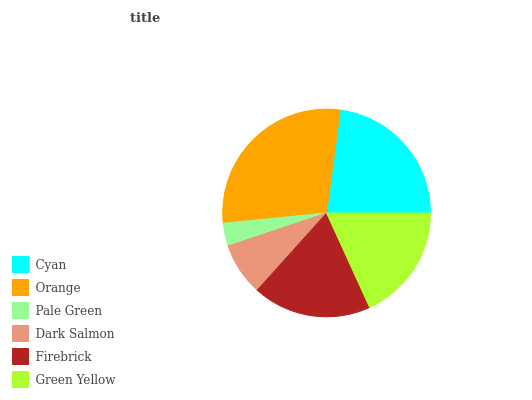Is Pale Green the minimum?
Answer yes or no. Yes. Is Orange the maximum?
Answer yes or no. Yes. Is Orange the minimum?
Answer yes or no. No. Is Pale Green the maximum?
Answer yes or no. No. Is Orange greater than Pale Green?
Answer yes or no. Yes. Is Pale Green less than Orange?
Answer yes or no. Yes. Is Pale Green greater than Orange?
Answer yes or no. No. Is Orange less than Pale Green?
Answer yes or no. No. Is Firebrick the high median?
Answer yes or no. Yes. Is Green Yellow the low median?
Answer yes or no. Yes. Is Pale Green the high median?
Answer yes or no. No. Is Firebrick the low median?
Answer yes or no. No. 